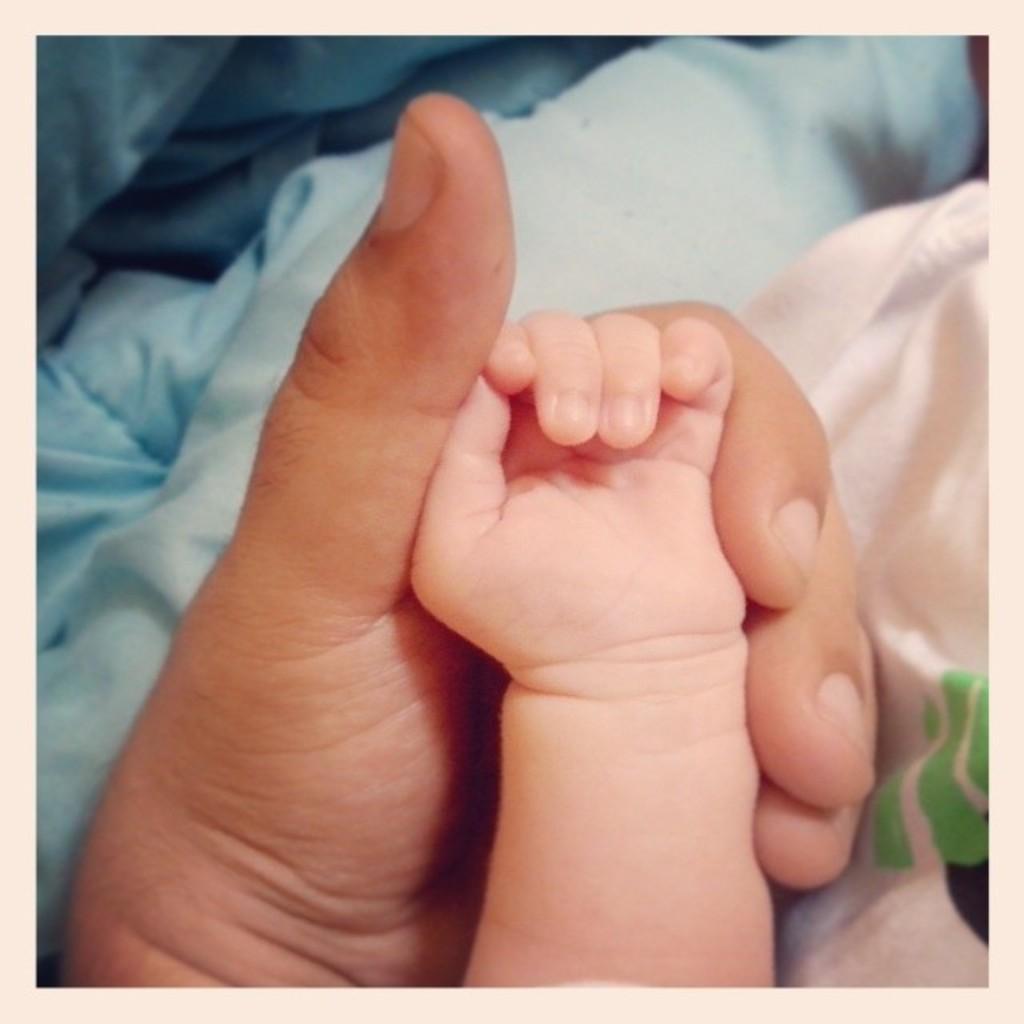Describe this image in one or two sentences. As we can see in the image there is a person hand holding child hand and there is white color bed sheet. 